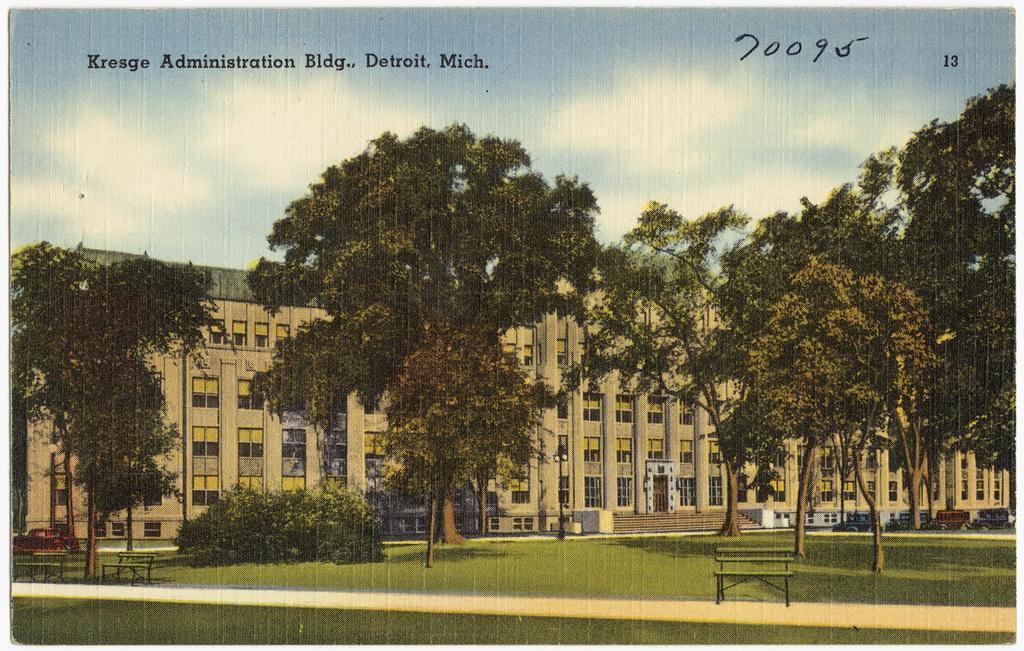Could you give a brief overview of what you see in this image? In this image I can see the road, few benches, some grass, few plants, few trees, few vehicles, few stairs and a building. I can see few windows of the building and the sky in the background. 